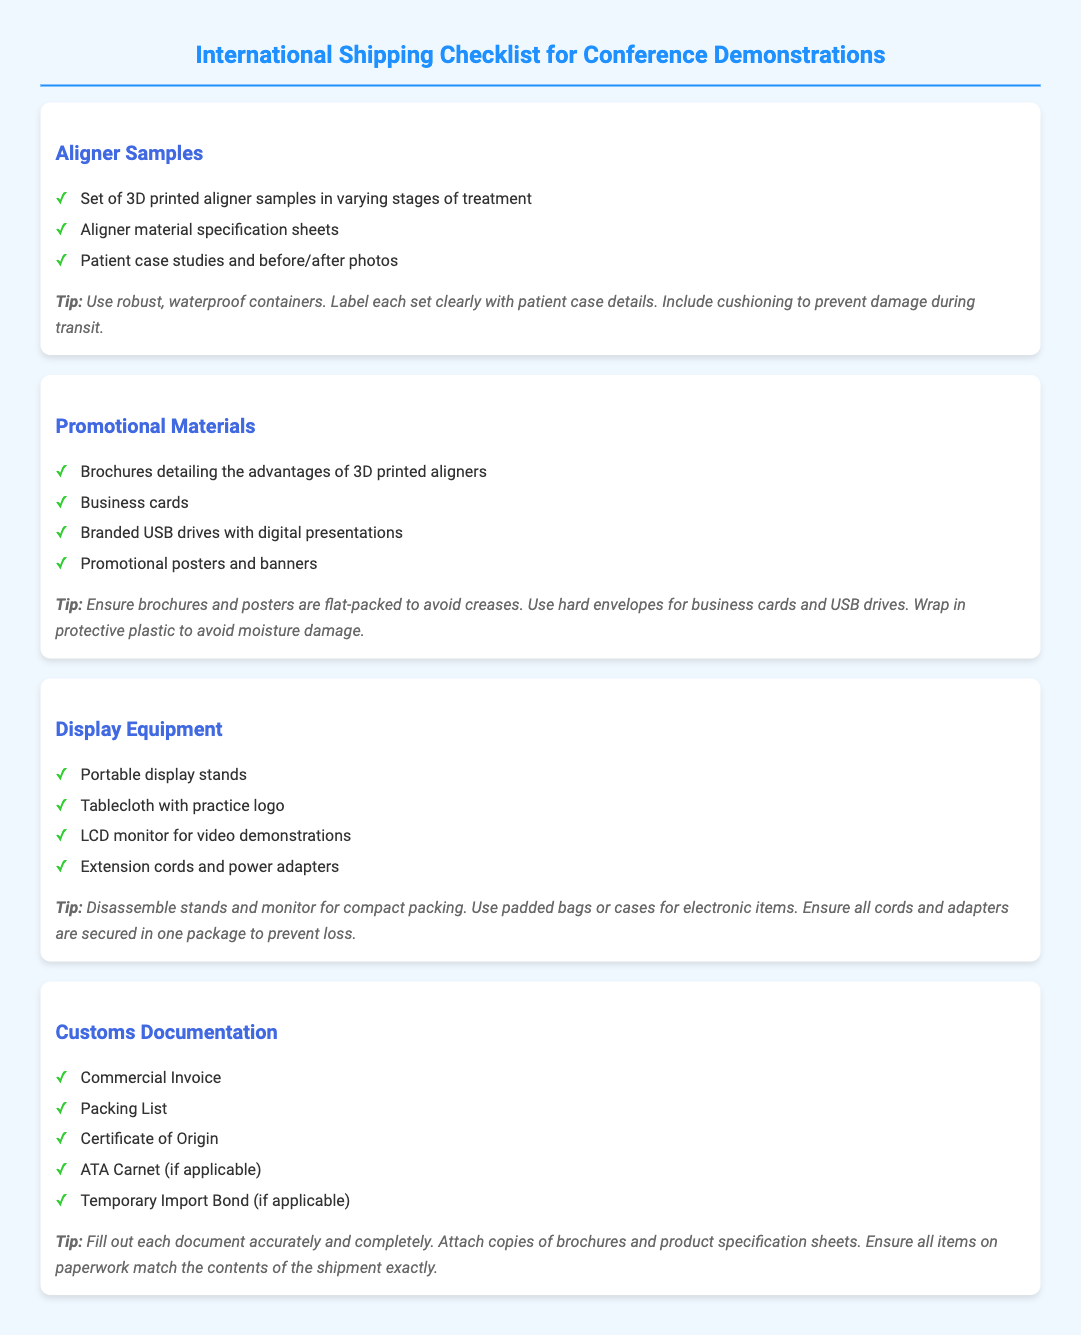What items are included in the aligner samples section? The aligner samples section includes a set of 3D printed aligner samples, aligner material specification sheets, and patient case studies with before/after photos.
Answer: Set of 3D printed aligner samples, aligner material specification sheets, patient case studies and before/after photos How many types of promotional materials are listed? The promotional materials section lists brochures, business cards, branded USB drives, and promotional posters and banners, totaling four types.
Answer: Four types What is advised for packing brochures and posters? The tips section advises ensuring brochures and posters are flat-packed to avoid creases.
Answer: Flat-packed Which document is necessary for customs that is also a packing list? The packing list itself is one of the necessary customs documents.
Answer: Packing List What type of container is recommended for aligner samples? The tips section recommends using robust, waterproof containers for aligner samples.
Answer: Robust, waterproof containers What should be included with customs documentation? The document specifies that copies of brochures and product specification sheets should be attached with customs documentation.
Answer: Copies of brochures and product specification sheets How should electronic items be packed? The tips for display equipment recommend using padded bags or cases for electronic items.
Answer: Padded bags or cases What type of display equipment is suggested? The display equipment section suggests portable display stands as one of the items.
Answer: Portable display stands 